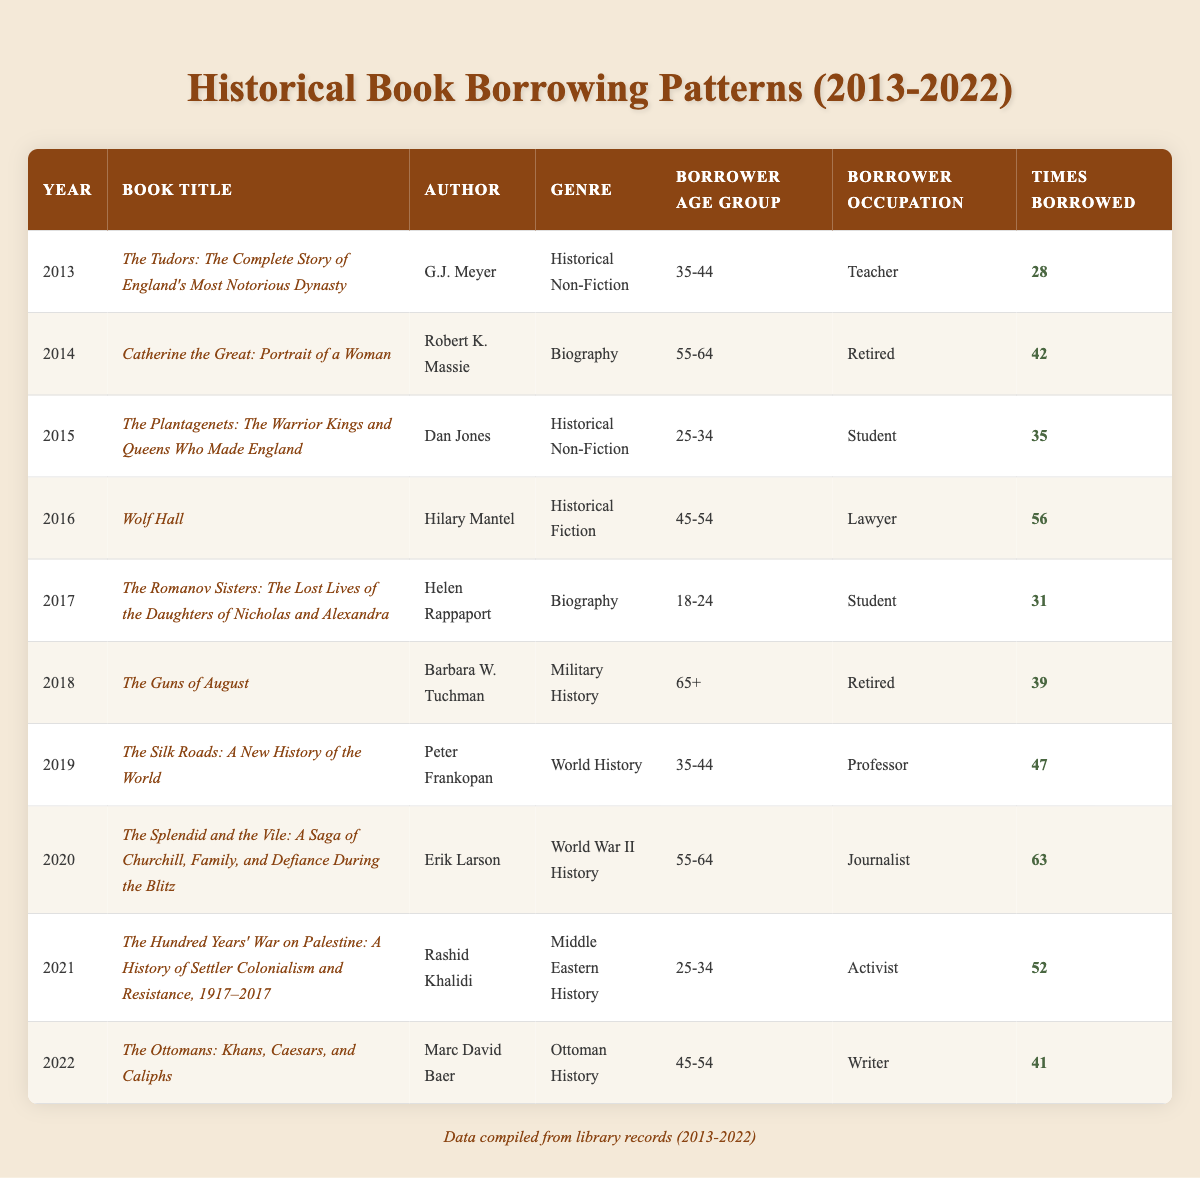What year had the highest number of times borrowed for historical fiction? In the table, I look through the rows for the genre "Historical Fiction." The only entry for this genre is "Wolf Hall" by Hilary Mantel in 2016, which was borrowed 56 times. Since it is the only instance, it is also the highest.
Answer: 2016 Which book was borrowed the most by individuals aged 55-64? I search for all rows with the borrower age group "55-64" and find two entries: "Catherine the Great: Portrait of a Woman," borrowed 42 times in 2014, and "The Splendid and the Vile," borrowed 63 times in 2020. "The Splendid and the Vile" has the higher borrow count.
Answer: The Splendid and the Vile What is the total number of times books were borrowed across all years? I sum the "Times Borrowed" values from all entries in the table: 28 + 42 + 35 + 56 + 31 + 39 + 47 + 63 + 52 + 41 =  439. The total count is 439.
Answer: 439 Did any student borrower borrow more than 60 times? I check the rows where the borrower occupation is "Student." The entries are "The Plantagenets" (35 times) in 2015 and "The Romanov Sisters" (31 times) in 2017. Since both counts are below 60, the answer is no.
Answer: No What genre was most popular in terms of total borrowings? I summarize the borrowings by genre: Historical Non-Fiction (28 + 35 = 63), Biography (42 + 31 = 73), Historical Fiction (56), Military History (39), World History (47), World War II History (63), Middle Eastern History (52), Ottoman History (41). By comparing the totals, Biography has 73, more than any other genre, making it the most popular.
Answer: Biography Which author wrote the book with the least borrowings? I review the "Times Borrowed" for each entry. The lowest borrow count is 28 for "The Tudors" by G.J. Meyer in 2013, so G.J. Meyer is the author who wrote the book with the least borrowings.
Answer: G.J. Meyer 